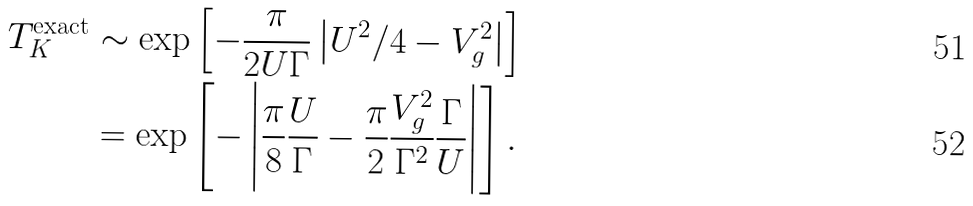<formula> <loc_0><loc_0><loc_500><loc_500>T _ { K } ^ { \text {exact} } & \sim \exp { \left [ - \frac { \pi } { 2 U \Gamma } \left | U ^ { 2 } / 4 - V _ { g } ^ { 2 } \right | \right ] } \\ & = \exp { \left [ - \left | \frac { \pi } { 8 } \frac { U } { \Gamma } - \frac { \pi } 2 \frac { V _ { g } ^ { 2 } } { \Gamma ^ { 2 } } \frac { \Gamma } { U } \right | \right ] } \, .</formula> 